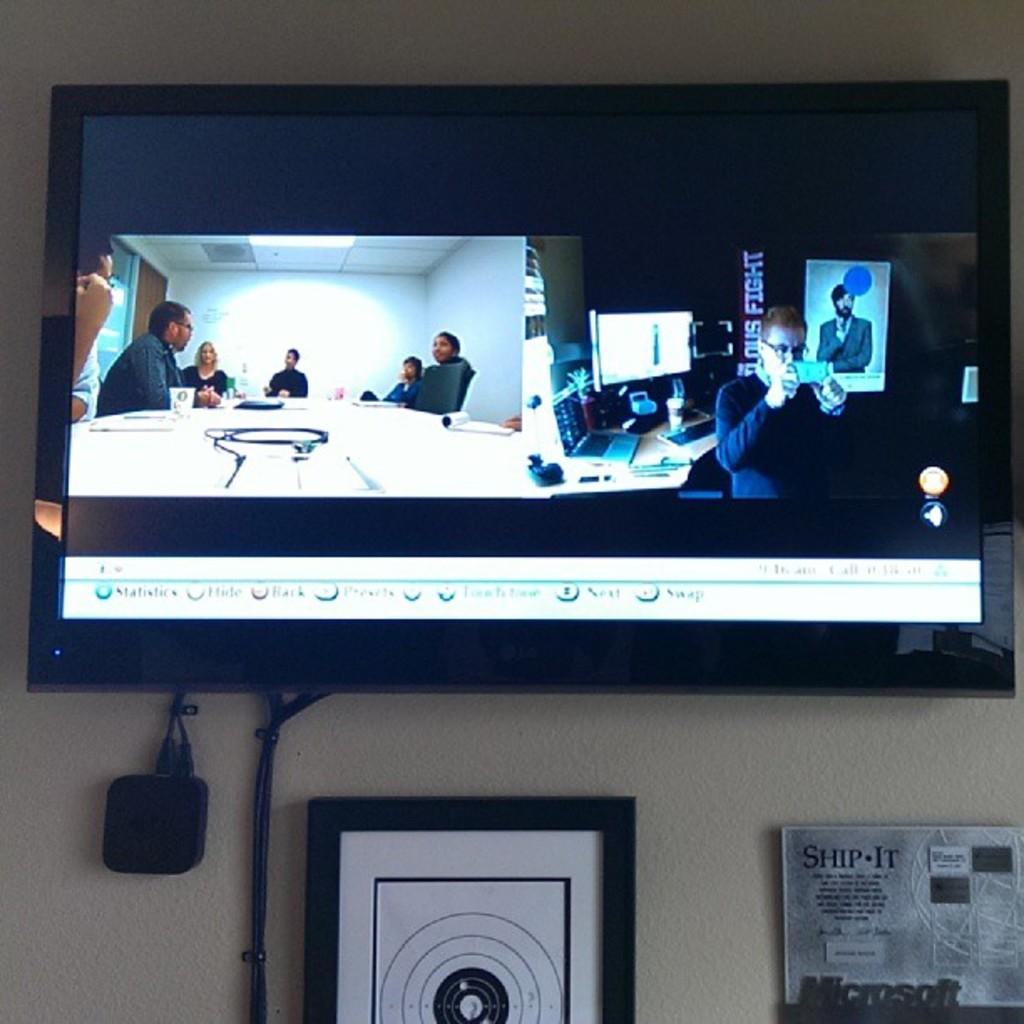<image>
Render a clear and concise summary of the photo. the word fight is on the sign next to the people 